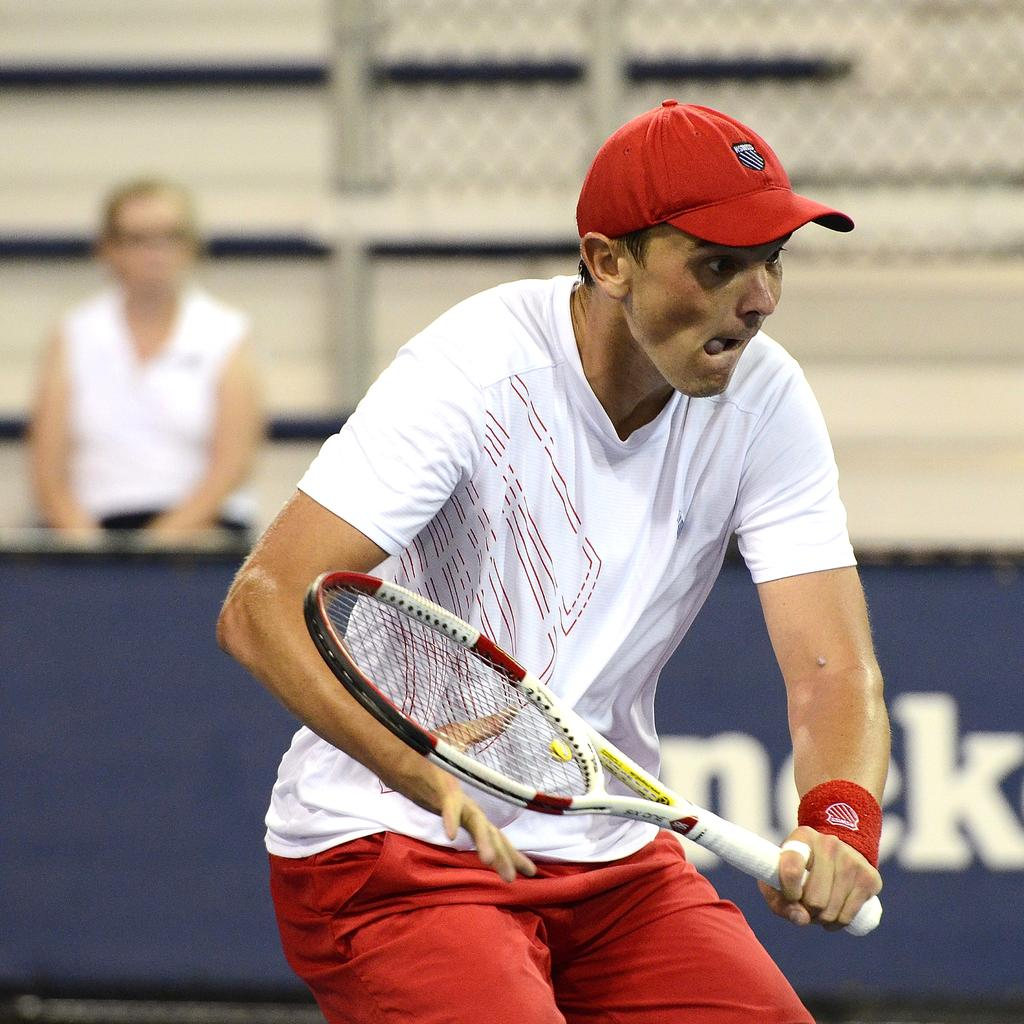Who is the main subject in the image? There is a man in the center of the image. What is the man holding in his hand? The man is holding a bat in his hand. What can be seen on the man's head? The man is wearing a red color cap on his head. What color is the board in the background of the image? There is a blue color board in the background of the image. Can you describe the woman's position in the image? There is a woman sitting in the background of the image. What language is the man speaking in the image? The image does not provide any information about the language being spoken by the man. What type of behavior is the woman exhibiting in the image? The image does not provide any information about the woman's behavior. 